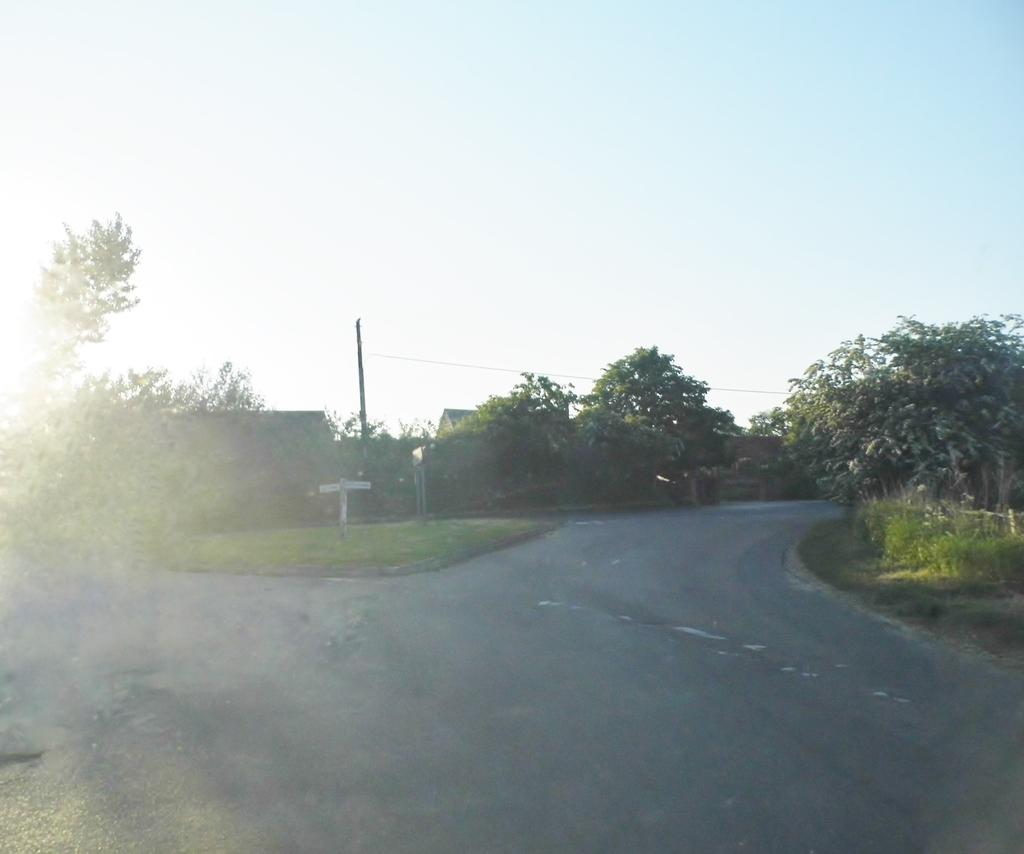What type of pathway is visible in the image? There is a road in the image. What type of vegetation can be seen in the image? There are trees and grass in the image. What is visible at the top of the image? The sky is visible at the top of the image. Reasoning: Let' Let's think step by step in order to produce the conversation. We start by identifying the main subjects and objects in the image based on the provided facts. We then formulate questions that focus on the location and characteristics of these subjects and objects, ensuring that each question can be answered definitively with the information given. We avoid yes/no questions and ensure that the language is simple and clear. Absurd Question/Answer: How many ants can be seen carrying a match across the road in the image? There are no ants or matches present in the image. What unit of measurement is used to determine the length of the grass in the image? The provided facts do not mention any specific unit of measurement for the grass in the image. 